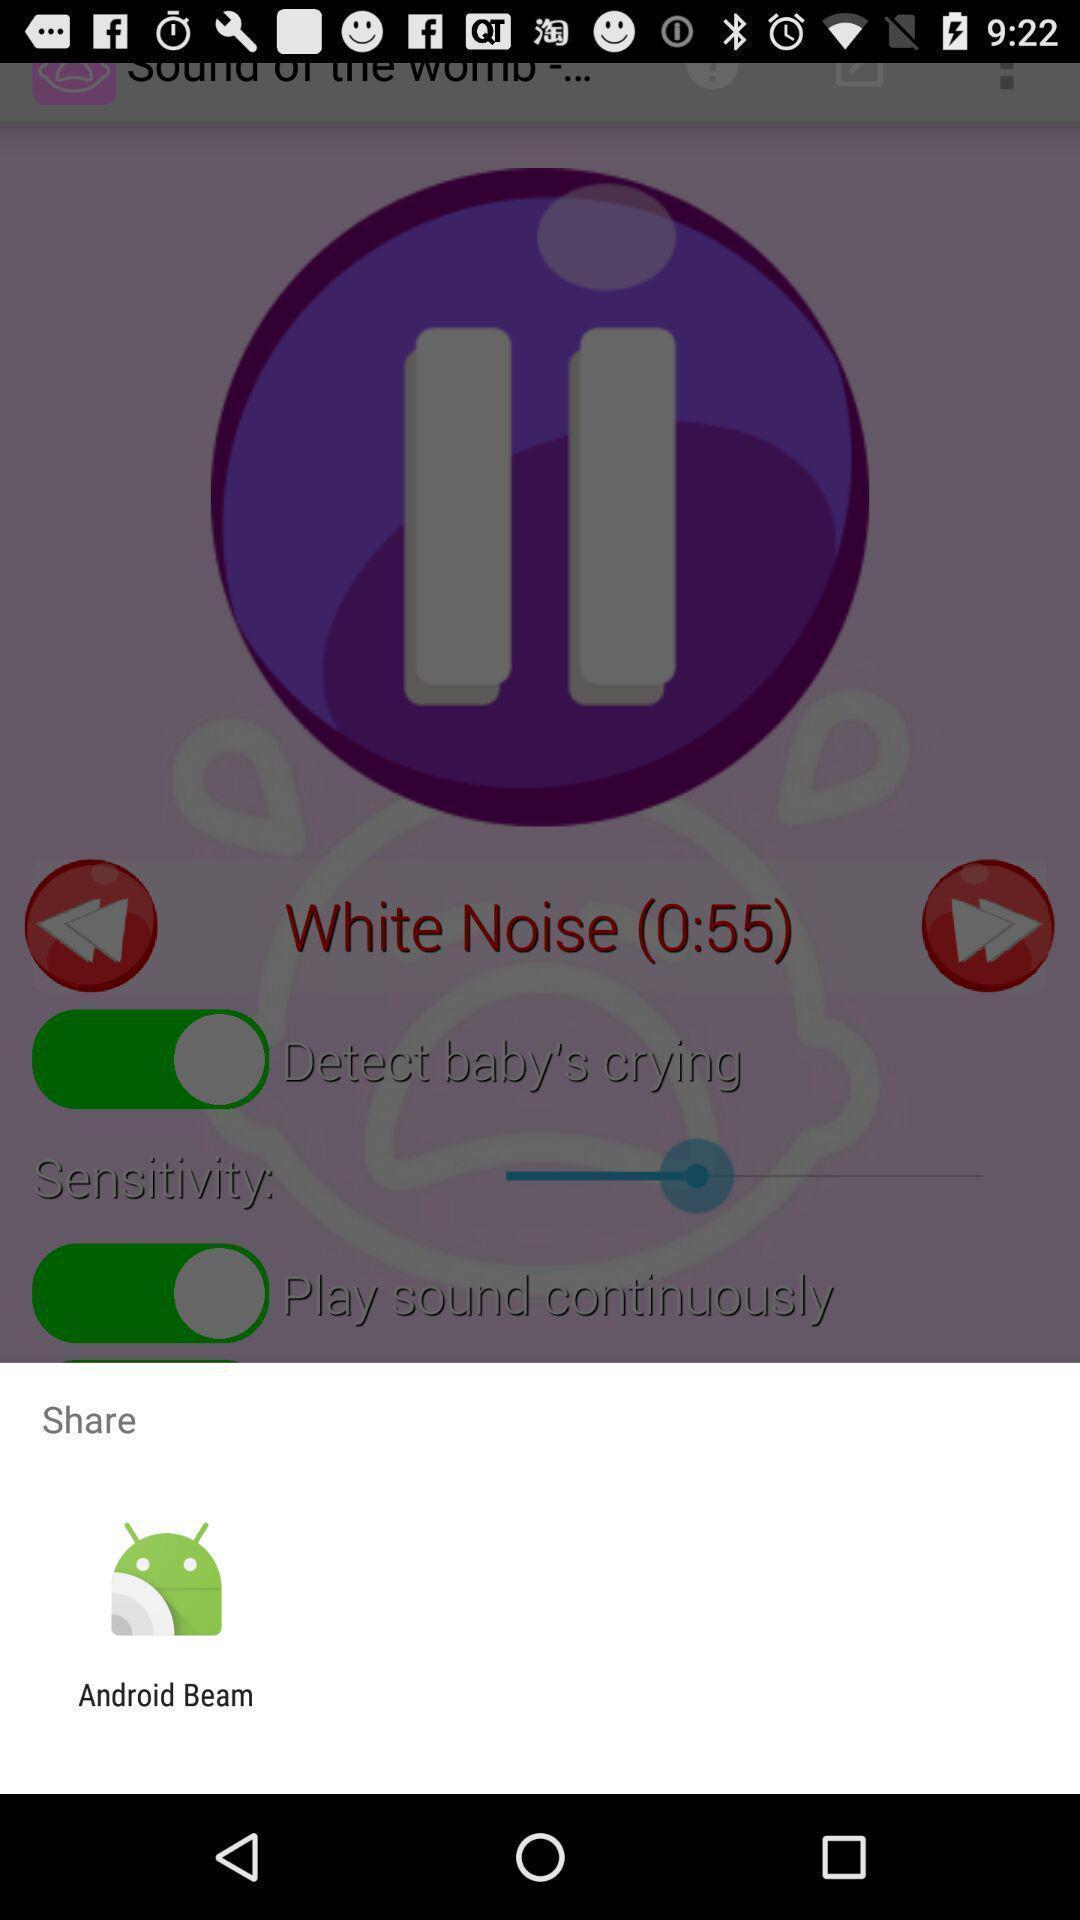What is the overall content of this screenshot? Pop up to share with different application. 